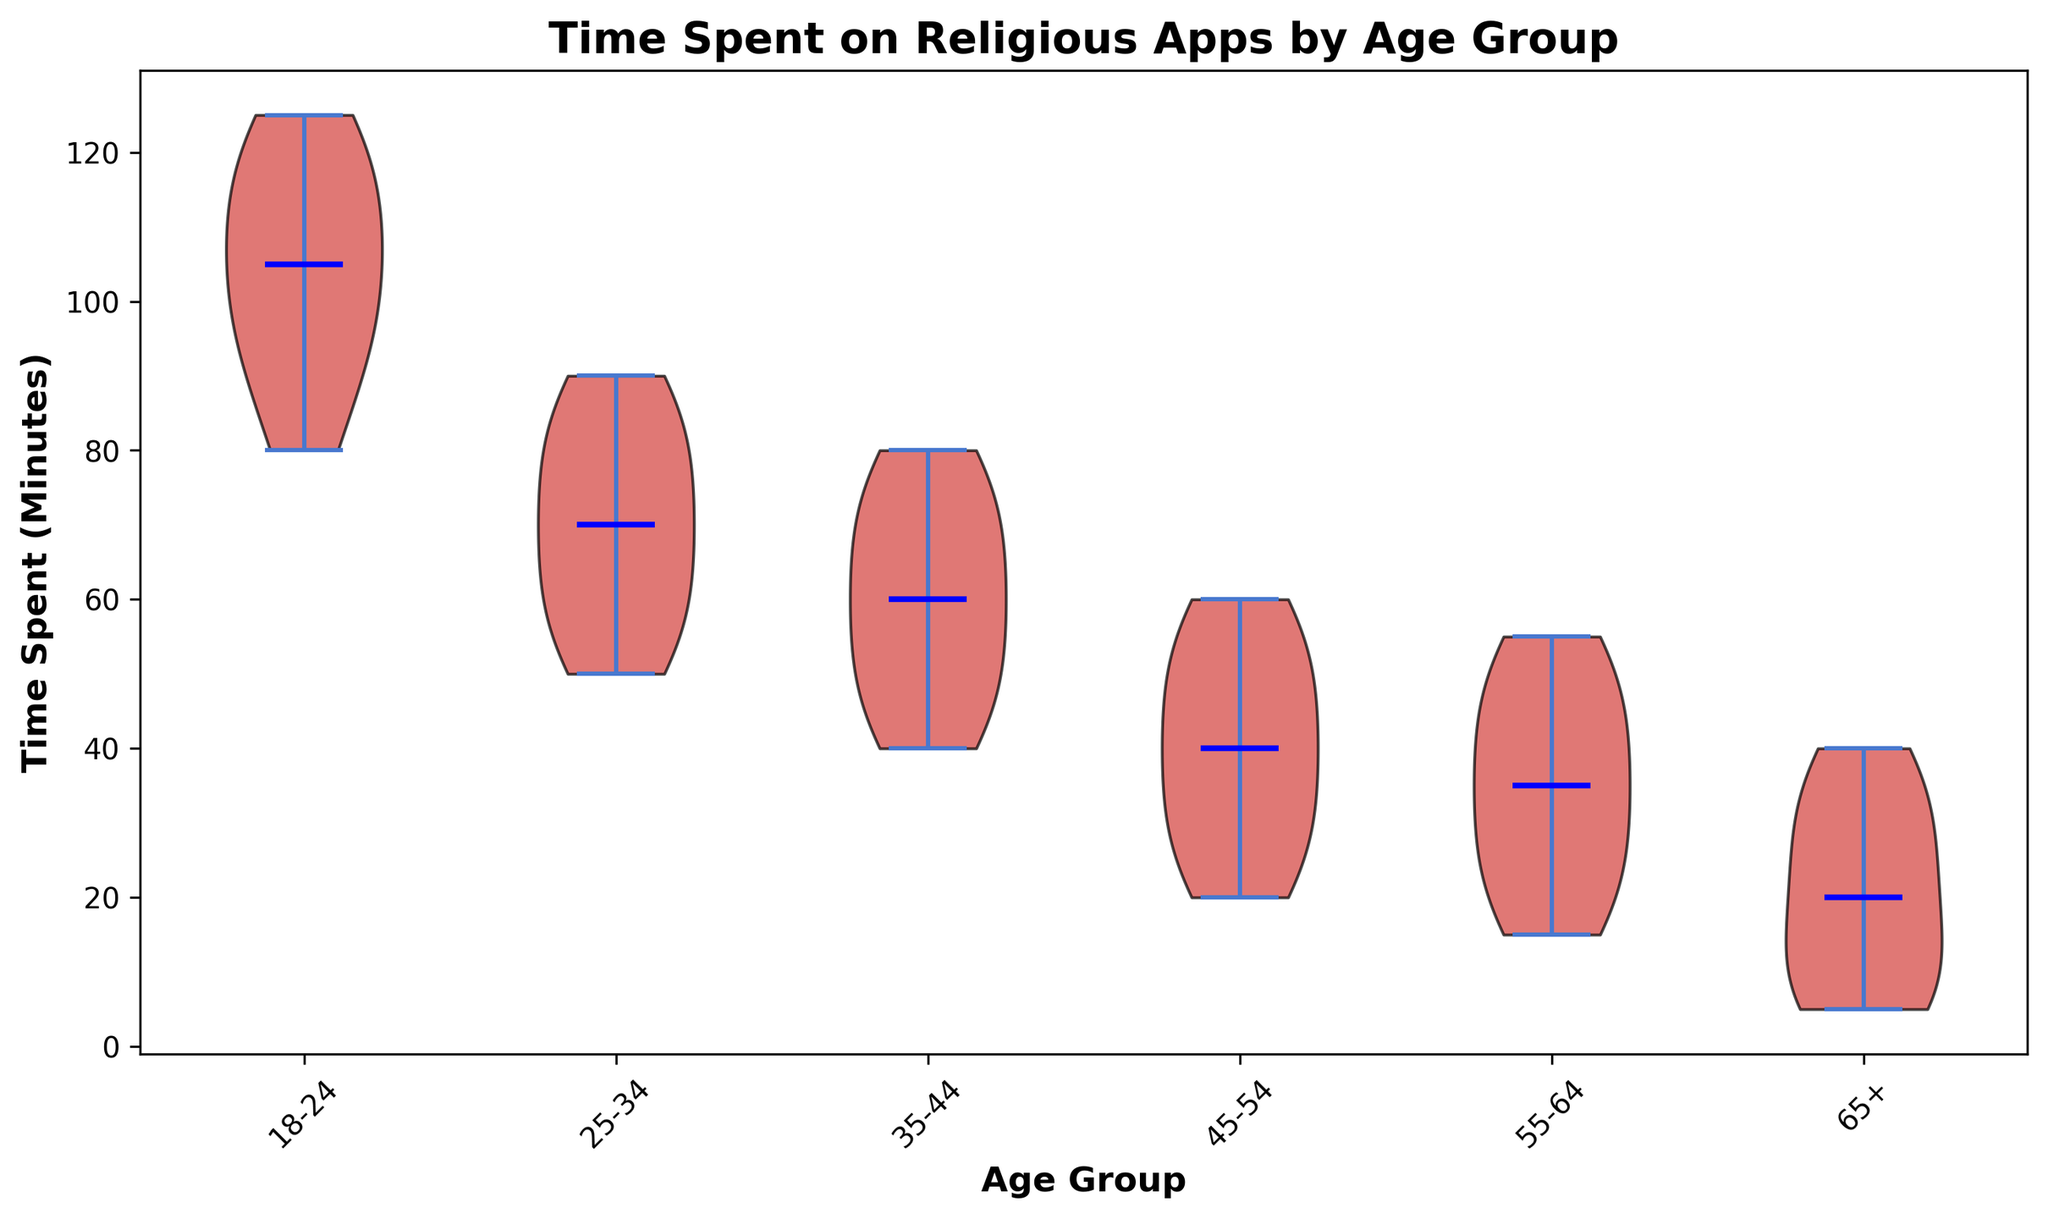What is the median time spent on religious apps for the 35-44 age group? The violin plot shows the median line for each age group. For the 35-44 age group, the median time spent is represented by the blue line inside the violin plot. By observing the plot, the blue line is at 60 minutes.
Answer: 60 minutes Compare the time spent on religious apps between the 18-24 and 65+ age groups. Which group spends more time, and by how much? By looking at the spread and length of the violin plots, we can determine the central tendency of the data. The median for the 18-24 group is around 105 minutes, and the median for the 65+ group is around 20 minutes. Subtracting these values, we get: 105 - 20 = 85 minutes. Hence, the 18-24 age group spends more time, specifically 85 minutes more than the 65+ group.
Answer: 18-24 by 85 minutes Which age group has the widest range of time spent on religious apps? The width of the violin plot represents the distribution spread. For the wider range, we look at the total spread from the bottom to the top. Observing the plot, the 18-24 age group shows the widest overall spread from approximately 80 minutes to 125 minutes.
Answer: 18-24 What is the difference between the median time spent on religious apps for the 25-34 and 45-54 age groups? The violin plot indicates the median for the 25-34 age group is around 70 minutes, and for the 45-54 age group, it is approximately 40 minutes. Calculating the difference: 70 - 40 = 30 minutes.
Answer: 30 minutes Which age group has the most consistent time spent on religious apps? Consistency in time spent can be visualized by the narrowness and tightness of the violin plot. The 55-64 age group's plot is narrow and tight, indicating less variability and hence more consistency around the median of 35 minutes.
Answer: 55-64 How much time, on average, do people in the 18-24 age group spend on religious apps? The average time is calculated by summing the values in the 18-24 group and dividing by the number of values. Sum = 120 + 90 + 110 + 80 + 100 + 95 + 105 + 115 + 125 = 940 minutes. Number of values = 9. Average = 940 / 9 ≈ 104.44 minutes.
Answer: ~104.44 minutes Does the 35-44 age group spend more or less time on religious apps than the 25-34 age group? By comparing the median lines, the median time for the 35-44 age group is around 60 minutes, while for the 25-34 age group, it is about 70 minutes. Thus, the 35-44 age group spends less time.
Answer: Less time 